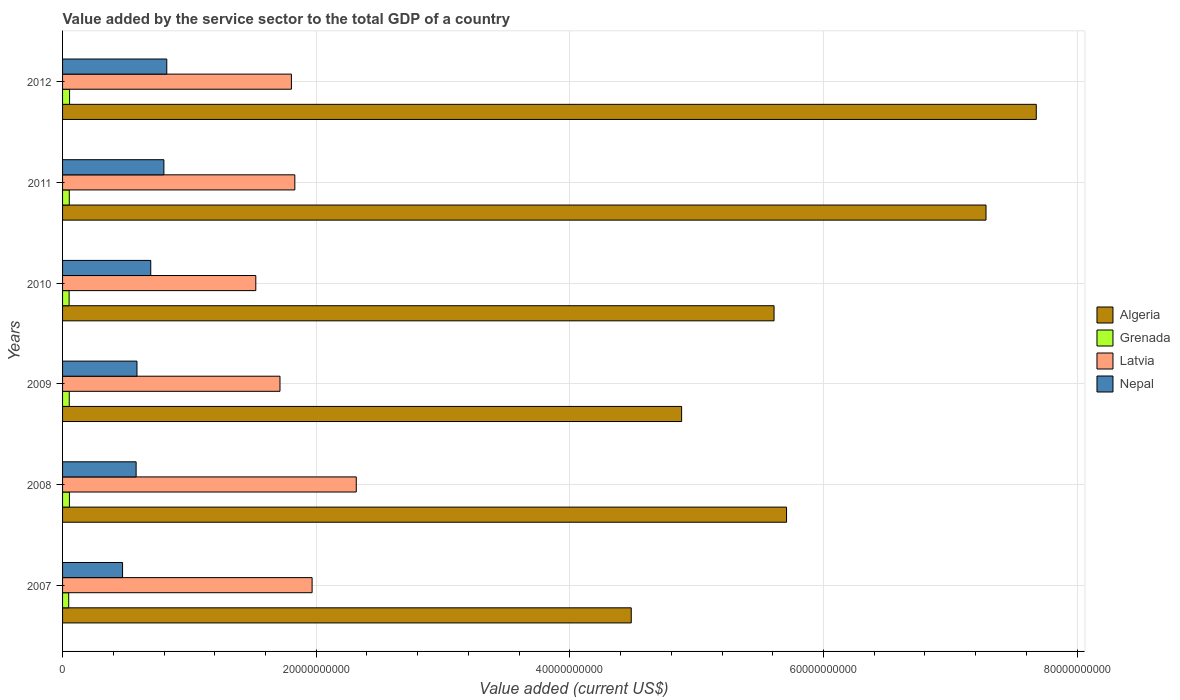Are the number of bars per tick equal to the number of legend labels?
Keep it short and to the point. Yes. How many bars are there on the 3rd tick from the top?
Offer a terse response. 4. How many bars are there on the 5th tick from the bottom?
Your answer should be compact. 4. What is the label of the 6th group of bars from the top?
Provide a short and direct response. 2007. In how many cases, is the number of bars for a given year not equal to the number of legend labels?
Ensure brevity in your answer.  0. What is the value added by the service sector to the total GDP in Nepal in 2012?
Your answer should be compact. 8.22e+09. Across all years, what is the maximum value added by the service sector to the total GDP in Algeria?
Offer a terse response. 7.68e+1. Across all years, what is the minimum value added by the service sector to the total GDP in Grenada?
Offer a very short reply. 4.83e+08. In which year was the value added by the service sector to the total GDP in Nepal minimum?
Your response must be concise. 2007. What is the total value added by the service sector to the total GDP in Nepal in the graph?
Provide a short and direct response. 3.96e+1. What is the difference between the value added by the service sector to the total GDP in Latvia in 2010 and that in 2011?
Provide a succinct answer. -3.08e+09. What is the difference between the value added by the service sector to the total GDP in Algeria in 2011 and the value added by the service sector to the total GDP in Latvia in 2008?
Offer a very short reply. 4.97e+1. What is the average value added by the service sector to the total GDP in Grenada per year?
Keep it short and to the point. 5.25e+08. In the year 2012, what is the difference between the value added by the service sector to the total GDP in Latvia and value added by the service sector to the total GDP in Grenada?
Ensure brevity in your answer.  1.75e+1. What is the ratio of the value added by the service sector to the total GDP in Grenada in 2008 to that in 2009?
Make the answer very short. 1.03. Is the value added by the service sector to the total GDP in Algeria in 2009 less than that in 2011?
Your answer should be very brief. Yes. What is the difference between the highest and the second highest value added by the service sector to the total GDP in Algeria?
Offer a terse response. 3.96e+09. What is the difference between the highest and the lowest value added by the service sector to the total GDP in Algeria?
Your answer should be compact. 3.19e+1. In how many years, is the value added by the service sector to the total GDP in Grenada greater than the average value added by the service sector to the total GDP in Grenada taken over all years?
Your answer should be compact. 4. Is the sum of the value added by the service sector to the total GDP in Algeria in 2009 and 2010 greater than the maximum value added by the service sector to the total GDP in Latvia across all years?
Offer a terse response. Yes. What does the 2nd bar from the top in 2007 represents?
Your answer should be compact. Latvia. What does the 3rd bar from the bottom in 2012 represents?
Keep it short and to the point. Latvia. Is it the case that in every year, the sum of the value added by the service sector to the total GDP in Nepal and value added by the service sector to the total GDP in Grenada is greater than the value added by the service sector to the total GDP in Algeria?
Provide a succinct answer. No. How many bars are there?
Your answer should be compact. 24. Does the graph contain any zero values?
Provide a short and direct response. No. Where does the legend appear in the graph?
Offer a terse response. Center right. How many legend labels are there?
Offer a terse response. 4. What is the title of the graph?
Ensure brevity in your answer.  Value added by the service sector to the total GDP of a country. What is the label or title of the X-axis?
Your answer should be compact. Value added (current US$). What is the label or title of the Y-axis?
Keep it short and to the point. Years. What is the Value added (current US$) of Algeria in 2007?
Your response must be concise. 4.48e+1. What is the Value added (current US$) in Grenada in 2007?
Provide a short and direct response. 4.83e+08. What is the Value added (current US$) of Latvia in 2007?
Make the answer very short. 1.97e+1. What is the Value added (current US$) of Nepal in 2007?
Offer a terse response. 4.73e+09. What is the Value added (current US$) of Algeria in 2008?
Make the answer very short. 5.71e+1. What is the Value added (current US$) in Grenada in 2008?
Keep it short and to the point. 5.40e+08. What is the Value added (current US$) of Latvia in 2008?
Provide a succinct answer. 2.32e+1. What is the Value added (current US$) of Nepal in 2008?
Keep it short and to the point. 5.80e+09. What is the Value added (current US$) of Algeria in 2009?
Your answer should be compact. 4.88e+1. What is the Value added (current US$) of Grenada in 2009?
Offer a terse response. 5.27e+08. What is the Value added (current US$) of Latvia in 2009?
Ensure brevity in your answer.  1.71e+1. What is the Value added (current US$) in Nepal in 2009?
Your answer should be compact. 5.87e+09. What is the Value added (current US$) in Algeria in 2010?
Ensure brevity in your answer.  5.61e+1. What is the Value added (current US$) of Grenada in 2010?
Your answer should be very brief. 5.17e+08. What is the Value added (current US$) of Latvia in 2010?
Provide a succinct answer. 1.52e+1. What is the Value added (current US$) in Nepal in 2010?
Ensure brevity in your answer.  6.95e+09. What is the Value added (current US$) of Algeria in 2011?
Provide a succinct answer. 7.28e+1. What is the Value added (current US$) in Grenada in 2011?
Your answer should be very brief. 5.30e+08. What is the Value added (current US$) in Latvia in 2011?
Offer a terse response. 1.83e+1. What is the Value added (current US$) of Nepal in 2011?
Offer a terse response. 7.99e+09. What is the Value added (current US$) in Algeria in 2012?
Ensure brevity in your answer.  7.68e+1. What is the Value added (current US$) of Grenada in 2012?
Keep it short and to the point. 5.53e+08. What is the Value added (current US$) of Latvia in 2012?
Keep it short and to the point. 1.80e+1. What is the Value added (current US$) of Nepal in 2012?
Ensure brevity in your answer.  8.22e+09. Across all years, what is the maximum Value added (current US$) in Algeria?
Give a very brief answer. 7.68e+1. Across all years, what is the maximum Value added (current US$) of Grenada?
Ensure brevity in your answer.  5.53e+08. Across all years, what is the maximum Value added (current US$) in Latvia?
Ensure brevity in your answer.  2.32e+1. Across all years, what is the maximum Value added (current US$) of Nepal?
Give a very brief answer. 8.22e+09. Across all years, what is the minimum Value added (current US$) in Algeria?
Give a very brief answer. 4.48e+1. Across all years, what is the minimum Value added (current US$) in Grenada?
Your response must be concise. 4.83e+08. Across all years, what is the minimum Value added (current US$) of Latvia?
Make the answer very short. 1.52e+1. Across all years, what is the minimum Value added (current US$) in Nepal?
Ensure brevity in your answer.  4.73e+09. What is the total Value added (current US$) of Algeria in the graph?
Your answer should be compact. 3.56e+11. What is the total Value added (current US$) of Grenada in the graph?
Give a very brief answer. 3.15e+09. What is the total Value added (current US$) of Latvia in the graph?
Give a very brief answer. 1.12e+11. What is the total Value added (current US$) of Nepal in the graph?
Your answer should be compact. 3.96e+1. What is the difference between the Value added (current US$) in Algeria in 2007 and that in 2008?
Offer a terse response. -1.22e+1. What is the difference between the Value added (current US$) of Grenada in 2007 and that in 2008?
Offer a very short reply. -5.68e+07. What is the difference between the Value added (current US$) of Latvia in 2007 and that in 2008?
Your response must be concise. -3.48e+09. What is the difference between the Value added (current US$) in Nepal in 2007 and that in 2008?
Your response must be concise. -1.07e+09. What is the difference between the Value added (current US$) of Algeria in 2007 and that in 2009?
Your answer should be compact. -3.97e+09. What is the difference between the Value added (current US$) of Grenada in 2007 and that in 2009?
Give a very brief answer. -4.32e+07. What is the difference between the Value added (current US$) in Latvia in 2007 and that in 2009?
Offer a terse response. 2.53e+09. What is the difference between the Value added (current US$) in Nepal in 2007 and that in 2009?
Keep it short and to the point. -1.14e+09. What is the difference between the Value added (current US$) in Algeria in 2007 and that in 2010?
Provide a succinct answer. -1.13e+1. What is the difference between the Value added (current US$) in Grenada in 2007 and that in 2010?
Offer a very short reply. -3.40e+07. What is the difference between the Value added (current US$) of Latvia in 2007 and that in 2010?
Ensure brevity in your answer.  4.44e+09. What is the difference between the Value added (current US$) of Nepal in 2007 and that in 2010?
Keep it short and to the point. -2.22e+09. What is the difference between the Value added (current US$) in Algeria in 2007 and that in 2011?
Provide a short and direct response. -2.80e+1. What is the difference between the Value added (current US$) in Grenada in 2007 and that in 2011?
Keep it short and to the point. -4.61e+07. What is the difference between the Value added (current US$) in Latvia in 2007 and that in 2011?
Make the answer very short. 1.36e+09. What is the difference between the Value added (current US$) of Nepal in 2007 and that in 2011?
Your answer should be compact. -3.26e+09. What is the difference between the Value added (current US$) of Algeria in 2007 and that in 2012?
Provide a short and direct response. -3.19e+1. What is the difference between the Value added (current US$) in Grenada in 2007 and that in 2012?
Your response must be concise. -6.97e+07. What is the difference between the Value added (current US$) of Latvia in 2007 and that in 2012?
Keep it short and to the point. 1.63e+09. What is the difference between the Value added (current US$) in Nepal in 2007 and that in 2012?
Ensure brevity in your answer.  -3.49e+09. What is the difference between the Value added (current US$) of Algeria in 2008 and that in 2009?
Ensure brevity in your answer.  8.27e+09. What is the difference between the Value added (current US$) of Grenada in 2008 and that in 2009?
Your answer should be very brief. 1.36e+07. What is the difference between the Value added (current US$) of Latvia in 2008 and that in 2009?
Offer a terse response. 6.01e+09. What is the difference between the Value added (current US$) of Nepal in 2008 and that in 2009?
Your response must be concise. -6.65e+07. What is the difference between the Value added (current US$) of Algeria in 2008 and that in 2010?
Your response must be concise. 9.84e+08. What is the difference between the Value added (current US$) of Grenada in 2008 and that in 2010?
Provide a succinct answer. 2.28e+07. What is the difference between the Value added (current US$) of Latvia in 2008 and that in 2010?
Keep it short and to the point. 7.92e+09. What is the difference between the Value added (current US$) in Nepal in 2008 and that in 2010?
Offer a very short reply. -1.15e+09. What is the difference between the Value added (current US$) in Algeria in 2008 and that in 2011?
Your answer should be very brief. -1.57e+1. What is the difference between the Value added (current US$) of Grenada in 2008 and that in 2011?
Your answer should be very brief. 1.06e+07. What is the difference between the Value added (current US$) in Latvia in 2008 and that in 2011?
Provide a succinct answer. 4.84e+09. What is the difference between the Value added (current US$) of Nepal in 2008 and that in 2011?
Your response must be concise. -2.19e+09. What is the difference between the Value added (current US$) of Algeria in 2008 and that in 2012?
Make the answer very short. -1.97e+1. What is the difference between the Value added (current US$) in Grenada in 2008 and that in 2012?
Your answer should be compact. -1.29e+07. What is the difference between the Value added (current US$) of Latvia in 2008 and that in 2012?
Make the answer very short. 5.11e+09. What is the difference between the Value added (current US$) in Nepal in 2008 and that in 2012?
Provide a succinct answer. -2.42e+09. What is the difference between the Value added (current US$) in Algeria in 2009 and that in 2010?
Offer a very short reply. -7.29e+09. What is the difference between the Value added (current US$) in Grenada in 2009 and that in 2010?
Keep it short and to the point. 9.20e+06. What is the difference between the Value added (current US$) in Latvia in 2009 and that in 2010?
Give a very brief answer. 1.91e+09. What is the difference between the Value added (current US$) in Nepal in 2009 and that in 2010?
Provide a succinct answer. -1.09e+09. What is the difference between the Value added (current US$) of Algeria in 2009 and that in 2011?
Provide a succinct answer. -2.40e+1. What is the difference between the Value added (current US$) of Grenada in 2009 and that in 2011?
Make the answer very short. -2.93e+06. What is the difference between the Value added (current US$) in Latvia in 2009 and that in 2011?
Offer a very short reply. -1.17e+09. What is the difference between the Value added (current US$) of Nepal in 2009 and that in 2011?
Your answer should be compact. -2.12e+09. What is the difference between the Value added (current US$) of Algeria in 2009 and that in 2012?
Make the answer very short. -2.80e+1. What is the difference between the Value added (current US$) in Grenada in 2009 and that in 2012?
Keep it short and to the point. -2.65e+07. What is the difference between the Value added (current US$) in Latvia in 2009 and that in 2012?
Offer a terse response. -9.00e+08. What is the difference between the Value added (current US$) in Nepal in 2009 and that in 2012?
Give a very brief answer. -2.35e+09. What is the difference between the Value added (current US$) of Algeria in 2010 and that in 2011?
Your response must be concise. -1.67e+1. What is the difference between the Value added (current US$) of Grenada in 2010 and that in 2011?
Offer a very short reply. -1.21e+07. What is the difference between the Value added (current US$) in Latvia in 2010 and that in 2011?
Your response must be concise. -3.08e+09. What is the difference between the Value added (current US$) of Nepal in 2010 and that in 2011?
Your answer should be very brief. -1.04e+09. What is the difference between the Value added (current US$) of Algeria in 2010 and that in 2012?
Provide a short and direct response. -2.07e+1. What is the difference between the Value added (current US$) of Grenada in 2010 and that in 2012?
Your answer should be very brief. -3.57e+07. What is the difference between the Value added (current US$) of Latvia in 2010 and that in 2012?
Ensure brevity in your answer.  -2.81e+09. What is the difference between the Value added (current US$) of Nepal in 2010 and that in 2012?
Offer a very short reply. -1.26e+09. What is the difference between the Value added (current US$) in Algeria in 2011 and that in 2012?
Your response must be concise. -3.96e+09. What is the difference between the Value added (current US$) in Grenada in 2011 and that in 2012?
Ensure brevity in your answer.  -2.36e+07. What is the difference between the Value added (current US$) of Latvia in 2011 and that in 2012?
Provide a short and direct response. 2.70e+08. What is the difference between the Value added (current US$) of Nepal in 2011 and that in 2012?
Ensure brevity in your answer.  -2.28e+08. What is the difference between the Value added (current US$) of Algeria in 2007 and the Value added (current US$) of Grenada in 2008?
Make the answer very short. 4.43e+1. What is the difference between the Value added (current US$) in Algeria in 2007 and the Value added (current US$) in Latvia in 2008?
Offer a very short reply. 2.17e+1. What is the difference between the Value added (current US$) of Algeria in 2007 and the Value added (current US$) of Nepal in 2008?
Make the answer very short. 3.90e+1. What is the difference between the Value added (current US$) in Grenada in 2007 and the Value added (current US$) in Latvia in 2008?
Ensure brevity in your answer.  -2.27e+1. What is the difference between the Value added (current US$) in Grenada in 2007 and the Value added (current US$) in Nepal in 2008?
Provide a short and direct response. -5.32e+09. What is the difference between the Value added (current US$) in Latvia in 2007 and the Value added (current US$) in Nepal in 2008?
Give a very brief answer. 1.39e+1. What is the difference between the Value added (current US$) in Algeria in 2007 and the Value added (current US$) in Grenada in 2009?
Make the answer very short. 4.43e+1. What is the difference between the Value added (current US$) of Algeria in 2007 and the Value added (current US$) of Latvia in 2009?
Keep it short and to the point. 2.77e+1. What is the difference between the Value added (current US$) in Algeria in 2007 and the Value added (current US$) in Nepal in 2009?
Your answer should be compact. 3.90e+1. What is the difference between the Value added (current US$) of Grenada in 2007 and the Value added (current US$) of Latvia in 2009?
Ensure brevity in your answer.  -1.67e+1. What is the difference between the Value added (current US$) in Grenada in 2007 and the Value added (current US$) in Nepal in 2009?
Ensure brevity in your answer.  -5.38e+09. What is the difference between the Value added (current US$) of Latvia in 2007 and the Value added (current US$) of Nepal in 2009?
Provide a short and direct response. 1.38e+1. What is the difference between the Value added (current US$) of Algeria in 2007 and the Value added (current US$) of Grenada in 2010?
Offer a very short reply. 4.43e+1. What is the difference between the Value added (current US$) in Algeria in 2007 and the Value added (current US$) in Latvia in 2010?
Offer a very short reply. 2.96e+1. What is the difference between the Value added (current US$) of Algeria in 2007 and the Value added (current US$) of Nepal in 2010?
Your answer should be very brief. 3.79e+1. What is the difference between the Value added (current US$) of Grenada in 2007 and the Value added (current US$) of Latvia in 2010?
Your answer should be very brief. -1.48e+1. What is the difference between the Value added (current US$) in Grenada in 2007 and the Value added (current US$) in Nepal in 2010?
Your answer should be compact. -6.47e+09. What is the difference between the Value added (current US$) of Latvia in 2007 and the Value added (current US$) of Nepal in 2010?
Your answer should be compact. 1.27e+1. What is the difference between the Value added (current US$) in Algeria in 2007 and the Value added (current US$) in Grenada in 2011?
Make the answer very short. 4.43e+1. What is the difference between the Value added (current US$) in Algeria in 2007 and the Value added (current US$) in Latvia in 2011?
Make the answer very short. 2.65e+1. What is the difference between the Value added (current US$) in Algeria in 2007 and the Value added (current US$) in Nepal in 2011?
Provide a short and direct response. 3.69e+1. What is the difference between the Value added (current US$) of Grenada in 2007 and the Value added (current US$) of Latvia in 2011?
Your answer should be very brief. -1.78e+1. What is the difference between the Value added (current US$) in Grenada in 2007 and the Value added (current US$) in Nepal in 2011?
Offer a terse response. -7.51e+09. What is the difference between the Value added (current US$) in Latvia in 2007 and the Value added (current US$) in Nepal in 2011?
Your answer should be compact. 1.17e+1. What is the difference between the Value added (current US$) in Algeria in 2007 and the Value added (current US$) in Grenada in 2012?
Offer a very short reply. 4.43e+1. What is the difference between the Value added (current US$) of Algeria in 2007 and the Value added (current US$) of Latvia in 2012?
Give a very brief answer. 2.68e+1. What is the difference between the Value added (current US$) in Algeria in 2007 and the Value added (current US$) in Nepal in 2012?
Provide a succinct answer. 3.66e+1. What is the difference between the Value added (current US$) in Grenada in 2007 and the Value added (current US$) in Latvia in 2012?
Offer a very short reply. -1.76e+1. What is the difference between the Value added (current US$) in Grenada in 2007 and the Value added (current US$) in Nepal in 2012?
Offer a terse response. -7.73e+09. What is the difference between the Value added (current US$) in Latvia in 2007 and the Value added (current US$) in Nepal in 2012?
Offer a terse response. 1.15e+1. What is the difference between the Value added (current US$) of Algeria in 2008 and the Value added (current US$) of Grenada in 2009?
Keep it short and to the point. 5.66e+1. What is the difference between the Value added (current US$) in Algeria in 2008 and the Value added (current US$) in Latvia in 2009?
Your response must be concise. 3.99e+1. What is the difference between the Value added (current US$) of Algeria in 2008 and the Value added (current US$) of Nepal in 2009?
Offer a terse response. 5.12e+1. What is the difference between the Value added (current US$) of Grenada in 2008 and the Value added (current US$) of Latvia in 2009?
Offer a terse response. -1.66e+1. What is the difference between the Value added (current US$) in Grenada in 2008 and the Value added (current US$) in Nepal in 2009?
Your answer should be very brief. -5.33e+09. What is the difference between the Value added (current US$) of Latvia in 2008 and the Value added (current US$) of Nepal in 2009?
Ensure brevity in your answer.  1.73e+1. What is the difference between the Value added (current US$) in Algeria in 2008 and the Value added (current US$) in Grenada in 2010?
Provide a succinct answer. 5.66e+1. What is the difference between the Value added (current US$) in Algeria in 2008 and the Value added (current US$) in Latvia in 2010?
Ensure brevity in your answer.  4.19e+1. What is the difference between the Value added (current US$) of Algeria in 2008 and the Value added (current US$) of Nepal in 2010?
Your response must be concise. 5.01e+1. What is the difference between the Value added (current US$) of Grenada in 2008 and the Value added (current US$) of Latvia in 2010?
Ensure brevity in your answer.  -1.47e+1. What is the difference between the Value added (current US$) in Grenada in 2008 and the Value added (current US$) in Nepal in 2010?
Provide a succinct answer. -6.41e+09. What is the difference between the Value added (current US$) in Latvia in 2008 and the Value added (current US$) in Nepal in 2010?
Ensure brevity in your answer.  1.62e+1. What is the difference between the Value added (current US$) in Algeria in 2008 and the Value added (current US$) in Grenada in 2011?
Provide a succinct answer. 5.66e+1. What is the difference between the Value added (current US$) of Algeria in 2008 and the Value added (current US$) of Latvia in 2011?
Keep it short and to the point. 3.88e+1. What is the difference between the Value added (current US$) in Algeria in 2008 and the Value added (current US$) in Nepal in 2011?
Provide a short and direct response. 4.91e+1. What is the difference between the Value added (current US$) of Grenada in 2008 and the Value added (current US$) of Latvia in 2011?
Offer a very short reply. -1.78e+1. What is the difference between the Value added (current US$) of Grenada in 2008 and the Value added (current US$) of Nepal in 2011?
Give a very brief answer. -7.45e+09. What is the difference between the Value added (current US$) in Latvia in 2008 and the Value added (current US$) in Nepal in 2011?
Ensure brevity in your answer.  1.52e+1. What is the difference between the Value added (current US$) in Algeria in 2008 and the Value added (current US$) in Grenada in 2012?
Provide a succinct answer. 5.65e+1. What is the difference between the Value added (current US$) in Algeria in 2008 and the Value added (current US$) in Latvia in 2012?
Your answer should be compact. 3.90e+1. What is the difference between the Value added (current US$) of Algeria in 2008 and the Value added (current US$) of Nepal in 2012?
Keep it short and to the point. 4.89e+1. What is the difference between the Value added (current US$) of Grenada in 2008 and the Value added (current US$) of Latvia in 2012?
Your response must be concise. -1.75e+1. What is the difference between the Value added (current US$) of Grenada in 2008 and the Value added (current US$) of Nepal in 2012?
Make the answer very short. -7.68e+09. What is the difference between the Value added (current US$) in Latvia in 2008 and the Value added (current US$) in Nepal in 2012?
Your answer should be compact. 1.49e+1. What is the difference between the Value added (current US$) of Algeria in 2009 and the Value added (current US$) of Grenada in 2010?
Your answer should be compact. 4.83e+1. What is the difference between the Value added (current US$) in Algeria in 2009 and the Value added (current US$) in Latvia in 2010?
Ensure brevity in your answer.  3.36e+1. What is the difference between the Value added (current US$) of Algeria in 2009 and the Value added (current US$) of Nepal in 2010?
Make the answer very short. 4.19e+1. What is the difference between the Value added (current US$) in Grenada in 2009 and the Value added (current US$) in Latvia in 2010?
Keep it short and to the point. -1.47e+1. What is the difference between the Value added (current US$) in Grenada in 2009 and the Value added (current US$) in Nepal in 2010?
Ensure brevity in your answer.  -6.43e+09. What is the difference between the Value added (current US$) in Latvia in 2009 and the Value added (current US$) in Nepal in 2010?
Keep it short and to the point. 1.02e+1. What is the difference between the Value added (current US$) in Algeria in 2009 and the Value added (current US$) in Grenada in 2011?
Your answer should be compact. 4.83e+1. What is the difference between the Value added (current US$) of Algeria in 2009 and the Value added (current US$) of Latvia in 2011?
Provide a succinct answer. 3.05e+1. What is the difference between the Value added (current US$) in Algeria in 2009 and the Value added (current US$) in Nepal in 2011?
Offer a terse response. 4.08e+1. What is the difference between the Value added (current US$) of Grenada in 2009 and the Value added (current US$) of Latvia in 2011?
Give a very brief answer. -1.78e+1. What is the difference between the Value added (current US$) of Grenada in 2009 and the Value added (current US$) of Nepal in 2011?
Provide a short and direct response. -7.46e+09. What is the difference between the Value added (current US$) of Latvia in 2009 and the Value added (current US$) of Nepal in 2011?
Provide a succinct answer. 9.15e+09. What is the difference between the Value added (current US$) in Algeria in 2009 and the Value added (current US$) in Grenada in 2012?
Provide a succinct answer. 4.83e+1. What is the difference between the Value added (current US$) in Algeria in 2009 and the Value added (current US$) in Latvia in 2012?
Offer a terse response. 3.08e+1. What is the difference between the Value added (current US$) in Algeria in 2009 and the Value added (current US$) in Nepal in 2012?
Give a very brief answer. 4.06e+1. What is the difference between the Value added (current US$) in Grenada in 2009 and the Value added (current US$) in Latvia in 2012?
Offer a terse response. -1.75e+1. What is the difference between the Value added (current US$) of Grenada in 2009 and the Value added (current US$) of Nepal in 2012?
Provide a succinct answer. -7.69e+09. What is the difference between the Value added (current US$) of Latvia in 2009 and the Value added (current US$) of Nepal in 2012?
Ensure brevity in your answer.  8.93e+09. What is the difference between the Value added (current US$) of Algeria in 2010 and the Value added (current US$) of Grenada in 2011?
Provide a short and direct response. 5.56e+1. What is the difference between the Value added (current US$) of Algeria in 2010 and the Value added (current US$) of Latvia in 2011?
Your response must be concise. 3.78e+1. What is the difference between the Value added (current US$) in Algeria in 2010 and the Value added (current US$) in Nepal in 2011?
Ensure brevity in your answer.  4.81e+1. What is the difference between the Value added (current US$) of Grenada in 2010 and the Value added (current US$) of Latvia in 2011?
Offer a terse response. -1.78e+1. What is the difference between the Value added (current US$) of Grenada in 2010 and the Value added (current US$) of Nepal in 2011?
Offer a terse response. -7.47e+09. What is the difference between the Value added (current US$) in Latvia in 2010 and the Value added (current US$) in Nepal in 2011?
Offer a terse response. 7.25e+09. What is the difference between the Value added (current US$) in Algeria in 2010 and the Value added (current US$) in Grenada in 2012?
Provide a short and direct response. 5.56e+1. What is the difference between the Value added (current US$) in Algeria in 2010 and the Value added (current US$) in Latvia in 2012?
Your response must be concise. 3.81e+1. What is the difference between the Value added (current US$) in Algeria in 2010 and the Value added (current US$) in Nepal in 2012?
Ensure brevity in your answer.  4.79e+1. What is the difference between the Value added (current US$) in Grenada in 2010 and the Value added (current US$) in Latvia in 2012?
Make the answer very short. -1.75e+1. What is the difference between the Value added (current US$) of Grenada in 2010 and the Value added (current US$) of Nepal in 2012?
Provide a succinct answer. -7.70e+09. What is the difference between the Value added (current US$) in Latvia in 2010 and the Value added (current US$) in Nepal in 2012?
Keep it short and to the point. 7.02e+09. What is the difference between the Value added (current US$) in Algeria in 2011 and the Value added (current US$) in Grenada in 2012?
Keep it short and to the point. 7.23e+1. What is the difference between the Value added (current US$) of Algeria in 2011 and the Value added (current US$) of Latvia in 2012?
Provide a short and direct response. 5.48e+1. What is the difference between the Value added (current US$) of Algeria in 2011 and the Value added (current US$) of Nepal in 2012?
Provide a succinct answer. 6.46e+1. What is the difference between the Value added (current US$) of Grenada in 2011 and the Value added (current US$) of Latvia in 2012?
Provide a short and direct response. -1.75e+1. What is the difference between the Value added (current US$) of Grenada in 2011 and the Value added (current US$) of Nepal in 2012?
Keep it short and to the point. -7.69e+09. What is the difference between the Value added (current US$) in Latvia in 2011 and the Value added (current US$) in Nepal in 2012?
Give a very brief answer. 1.01e+1. What is the average Value added (current US$) of Algeria per year?
Keep it short and to the point. 5.94e+1. What is the average Value added (current US$) of Grenada per year?
Give a very brief answer. 5.25e+08. What is the average Value added (current US$) of Latvia per year?
Your response must be concise. 1.86e+1. What is the average Value added (current US$) in Nepal per year?
Your answer should be compact. 6.59e+09. In the year 2007, what is the difference between the Value added (current US$) of Algeria and Value added (current US$) of Grenada?
Your answer should be very brief. 4.44e+1. In the year 2007, what is the difference between the Value added (current US$) in Algeria and Value added (current US$) in Latvia?
Provide a short and direct response. 2.52e+1. In the year 2007, what is the difference between the Value added (current US$) of Algeria and Value added (current US$) of Nepal?
Keep it short and to the point. 4.01e+1. In the year 2007, what is the difference between the Value added (current US$) of Grenada and Value added (current US$) of Latvia?
Make the answer very short. -1.92e+1. In the year 2007, what is the difference between the Value added (current US$) of Grenada and Value added (current US$) of Nepal?
Ensure brevity in your answer.  -4.25e+09. In the year 2007, what is the difference between the Value added (current US$) of Latvia and Value added (current US$) of Nepal?
Offer a very short reply. 1.49e+1. In the year 2008, what is the difference between the Value added (current US$) in Algeria and Value added (current US$) in Grenada?
Ensure brevity in your answer.  5.65e+1. In the year 2008, what is the difference between the Value added (current US$) in Algeria and Value added (current US$) in Latvia?
Your answer should be very brief. 3.39e+1. In the year 2008, what is the difference between the Value added (current US$) of Algeria and Value added (current US$) of Nepal?
Offer a very short reply. 5.13e+1. In the year 2008, what is the difference between the Value added (current US$) in Grenada and Value added (current US$) in Latvia?
Give a very brief answer. -2.26e+1. In the year 2008, what is the difference between the Value added (current US$) of Grenada and Value added (current US$) of Nepal?
Give a very brief answer. -5.26e+09. In the year 2008, what is the difference between the Value added (current US$) of Latvia and Value added (current US$) of Nepal?
Offer a terse response. 1.74e+1. In the year 2009, what is the difference between the Value added (current US$) of Algeria and Value added (current US$) of Grenada?
Provide a succinct answer. 4.83e+1. In the year 2009, what is the difference between the Value added (current US$) in Algeria and Value added (current US$) in Latvia?
Ensure brevity in your answer.  3.17e+1. In the year 2009, what is the difference between the Value added (current US$) in Algeria and Value added (current US$) in Nepal?
Offer a terse response. 4.29e+1. In the year 2009, what is the difference between the Value added (current US$) of Grenada and Value added (current US$) of Latvia?
Keep it short and to the point. -1.66e+1. In the year 2009, what is the difference between the Value added (current US$) in Grenada and Value added (current US$) in Nepal?
Keep it short and to the point. -5.34e+09. In the year 2009, what is the difference between the Value added (current US$) of Latvia and Value added (current US$) of Nepal?
Give a very brief answer. 1.13e+1. In the year 2010, what is the difference between the Value added (current US$) in Algeria and Value added (current US$) in Grenada?
Your response must be concise. 5.56e+1. In the year 2010, what is the difference between the Value added (current US$) in Algeria and Value added (current US$) in Latvia?
Ensure brevity in your answer.  4.09e+1. In the year 2010, what is the difference between the Value added (current US$) of Algeria and Value added (current US$) of Nepal?
Offer a very short reply. 4.92e+1. In the year 2010, what is the difference between the Value added (current US$) in Grenada and Value added (current US$) in Latvia?
Your answer should be compact. -1.47e+1. In the year 2010, what is the difference between the Value added (current US$) of Grenada and Value added (current US$) of Nepal?
Your answer should be very brief. -6.44e+09. In the year 2010, what is the difference between the Value added (current US$) of Latvia and Value added (current US$) of Nepal?
Ensure brevity in your answer.  8.28e+09. In the year 2011, what is the difference between the Value added (current US$) of Algeria and Value added (current US$) of Grenada?
Your answer should be very brief. 7.23e+1. In the year 2011, what is the difference between the Value added (current US$) in Algeria and Value added (current US$) in Latvia?
Your answer should be compact. 5.45e+1. In the year 2011, what is the difference between the Value added (current US$) of Algeria and Value added (current US$) of Nepal?
Your answer should be compact. 6.48e+1. In the year 2011, what is the difference between the Value added (current US$) of Grenada and Value added (current US$) of Latvia?
Offer a very short reply. -1.78e+1. In the year 2011, what is the difference between the Value added (current US$) in Grenada and Value added (current US$) in Nepal?
Keep it short and to the point. -7.46e+09. In the year 2011, what is the difference between the Value added (current US$) of Latvia and Value added (current US$) of Nepal?
Give a very brief answer. 1.03e+1. In the year 2012, what is the difference between the Value added (current US$) in Algeria and Value added (current US$) in Grenada?
Your answer should be compact. 7.62e+1. In the year 2012, what is the difference between the Value added (current US$) in Algeria and Value added (current US$) in Latvia?
Keep it short and to the point. 5.87e+1. In the year 2012, what is the difference between the Value added (current US$) in Algeria and Value added (current US$) in Nepal?
Your answer should be compact. 6.86e+1. In the year 2012, what is the difference between the Value added (current US$) of Grenada and Value added (current US$) of Latvia?
Provide a short and direct response. -1.75e+1. In the year 2012, what is the difference between the Value added (current US$) of Grenada and Value added (current US$) of Nepal?
Your answer should be compact. -7.66e+09. In the year 2012, what is the difference between the Value added (current US$) of Latvia and Value added (current US$) of Nepal?
Ensure brevity in your answer.  9.83e+09. What is the ratio of the Value added (current US$) in Algeria in 2007 to that in 2008?
Provide a succinct answer. 0.79. What is the ratio of the Value added (current US$) in Grenada in 2007 to that in 2008?
Offer a very short reply. 0.89. What is the ratio of the Value added (current US$) of Latvia in 2007 to that in 2008?
Offer a terse response. 0.85. What is the ratio of the Value added (current US$) of Nepal in 2007 to that in 2008?
Your answer should be very brief. 0.82. What is the ratio of the Value added (current US$) in Algeria in 2007 to that in 2009?
Ensure brevity in your answer.  0.92. What is the ratio of the Value added (current US$) of Grenada in 2007 to that in 2009?
Provide a succinct answer. 0.92. What is the ratio of the Value added (current US$) in Latvia in 2007 to that in 2009?
Make the answer very short. 1.15. What is the ratio of the Value added (current US$) in Nepal in 2007 to that in 2009?
Give a very brief answer. 0.81. What is the ratio of the Value added (current US$) of Algeria in 2007 to that in 2010?
Give a very brief answer. 0.8. What is the ratio of the Value added (current US$) of Grenada in 2007 to that in 2010?
Give a very brief answer. 0.93. What is the ratio of the Value added (current US$) of Latvia in 2007 to that in 2010?
Provide a succinct answer. 1.29. What is the ratio of the Value added (current US$) in Nepal in 2007 to that in 2010?
Provide a succinct answer. 0.68. What is the ratio of the Value added (current US$) of Algeria in 2007 to that in 2011?
Make the answer very short. 0.62. What is the ratio of the Value added (current US$) in Grenada in 2007 to that in 2011?
Make the answer very short. 0.91. What is the ratio of the Value added (current US$) of Latvia in 2007 to that in 2011?
Keep it short and to the point. 1.07. What is the ratio of the Value added (current US$) in Nepal in 2007 to that in 2011?
Provide a short and direct response. 0.59. What is the ratio of the Value added (current US$) of Algeria in 2007 to that in 2012?
Make the answer very short. 0.58. What is the ratio of the Value added (current US$) in Grenada in 2007 to that in 2012?
Your answer should be very brief. 0.87. What is the ratio of the Value added (current US$) of Latvia in 2007 to that in 2012?
Provide a succinct answer. 1.09. What is the ratio of the Value added (current US$) in Nepal in 2007 to that in 2012?
Offer a very short reply. 0.58. What is the ratio of the Value added (current US$) in Algeria in 2008 to that in 2009?
Provide a succinct answer. 1.17. What is the ratio of the Value added (current US$) in Grenada in 2008 to that in 2009?
Provide a succinct answer. 1.03. What is the ratio of the Value added (current US$) in Latvia in 2008 to that in 2009?
Your answer should be compact. 1.35. What is the ratio of the Value added (current US$) of Nepal in 2008 to that in 2009?
Make the answer very short. 0.99. What is the ratio of the Value added (current US$) in Algeria in 2008 to that in 2010?
Provide a short and direct response. 1.02. What is the ratio of the Value added (current US$) of Grenada in 2008 to that in 2010?
Your response must be concise. 1.04. What is the ratio of the Value added (current US$) of Latvia in 2008 to that in 2010?
Offer a very short reply. 1.52. What is the ratio of the Value added (current US$) in Nepal in 2008 to that in 2010?
Your answer should be compact. 0.83. What is the ratio of the Value added (current US$) of Algeria in 2008 to that in 2011?
Offer a very short reply. 0.78. What is the ratio of the Value added (current US$) in Grenada in 2008 to that in 2011?
Provide a succinct answer. 1.02. What is the ratio of the Value added (current US$) in Latvia in 2008 to that in 2011?
Your answer should be compact. 1.26. What is the ratio of the Value added (current US$) in Nepal in 2008 to that in 2011?
Ensure brevity in your answer.  0.73. What is the ratio of the Value added (current US$) of Algeria in 2008 to that in 2012?
Make the answer very short. 0.74. What is the ratio of the Value added (current US$) of Grenada in 2008 to that in 2012?
Make the answer very short. 0.98. What is the ratio of the Value added (current US$) of Latvia in 2008 to that in 2012?
Ensure brevity in your answer.  1.28. What is the ratio of the Value added (current US$) in Nepal in 2008 to that in 2012?
Give a very brief answer. 0.71. What is the ratio of the Value added (current US$) of Algeria in 2009 to that in 2010?
Keep it short and to the point. 0.87. What is the ratio of the Value added (current US$) in Grenada in 2009 to that in 2010?
Offer a very short reply. 1.02. What is the ratio of the Value added (current US$) of Latvia in 2009 to that in 2010?
Offer a very short reply. 1.13. What is the ratio of the Value added (current US$) in Nepal in 2009 to that in 2010?
Ensure brevity in your answer.  0.84. What is the ratio of the Value added (current US$) in Algeria in 2009 to that in 2011?
Ensure brevity in your answer.  0.67. What is the ratio of the Value added (current US$) in Latvia in 2009 to that in 2011?
Offer a very short reply. 0.94. What is the ratio of the Value added (current US$) of Nepal in 2009 to that in 2011?
Your response must be concise. 0.73. What is the ratio of the Value added (current US$) of Algeria in 2009 to that in 2012?
Provide a succinct answer. 0.64. What is the ratio of the Value added (current US$) in Grenada in 2009 to that in 2012?
Provide a short and direct response. 0.95. What is the ratio of the Value added (current US$) of Latvia in 2009 to that in 2012?
Make the answer very short. 0.95. What is the ratio of the Value added (current US$) of Nepal in 2009 to that in 2012?
Your answer should be compact. 0.71. What is the ratio of the Value added (current US$) of Algeria in 2010 to that in 2011?
Provide a succinct answer. 0.77. What is the ratio of the Value added (current US$) of Grenada in 2010 to that in 2011?
Provide a succinct answer. 0.98. What is the ratio of the Value added (current US$) in Latvia in 2010 to that in 2011?
Your response must be concise. 0.83. What is the ratio of the Value added (current US$) of Nepal in 2010 to that in 2011?
Your response must be concise. 0.87. What is the ratio of the Value added (current US$) of Algeria in 2010 to that in 2012?
Your answer should be very brief. 0.73. What is the ratio of the Value added (current US$) in Grenada in 2010 to that in 2012?
Ensure brevity in your answer.  0.94. What is the ratio of the Value added (current US$) in Latvia in 2010 to that in 2012?
Ensure brevity in your answer.  0.84. What is the ratio of the Value added (current US$) in Nepal in 2010 to that in 2012?
Provide a short and direct response. 0.85. What is the ratio of the Value added (current US$) in Algeria in 2011 to that in 2012?
Offer a terse response. 0.95. What is the ratio of the Value added (current US$) of Grenada in 2011 to that in 2012?
Your answer should be very brief. 0.96. What is the ratio of the Value added (current US$) of Latvia in 2011 to that in 2012?
Make the answer very short. 1.01. What is the ratio of the Value added (current US$) of Nepal in 2011 to that in 2012?
Ensure brevity in your answer.  0.97. What is the difference between the highest and the second highest Value added (current US$) of Algeria?
Give a very brief answer. 3.96e+09. What is the difference between the highest and the second highest Value added (current US$) of Grenada?
Provide a succinct answer. 1.29e+07. What is the difference between the highest and the second highest Value added (current US$) in Latvia?
Give a very brief answer. 3.48e+09. What is the difference between the highest and the second highest Value added (current US$) in Nepal?
Offer a very short reply. 2.28e+08. What is the difference between the highest and the lowest Value added (current US$) of Algeria?
Keep it short and to the point. 3.19e+1. What is the difference between the highest and the lowest Value added (current US$) of Grenada?
Make the answer very short. 6.97e+07. What is the difference between the highest and the lowest Value added (current US$) of Latvia?
Your answer should be compact. 7.92e+09. What is the difference between the highest and the lowest Value added (current US$) in Nepal?
Ensure brevity in your answer.  3.49e+09. 